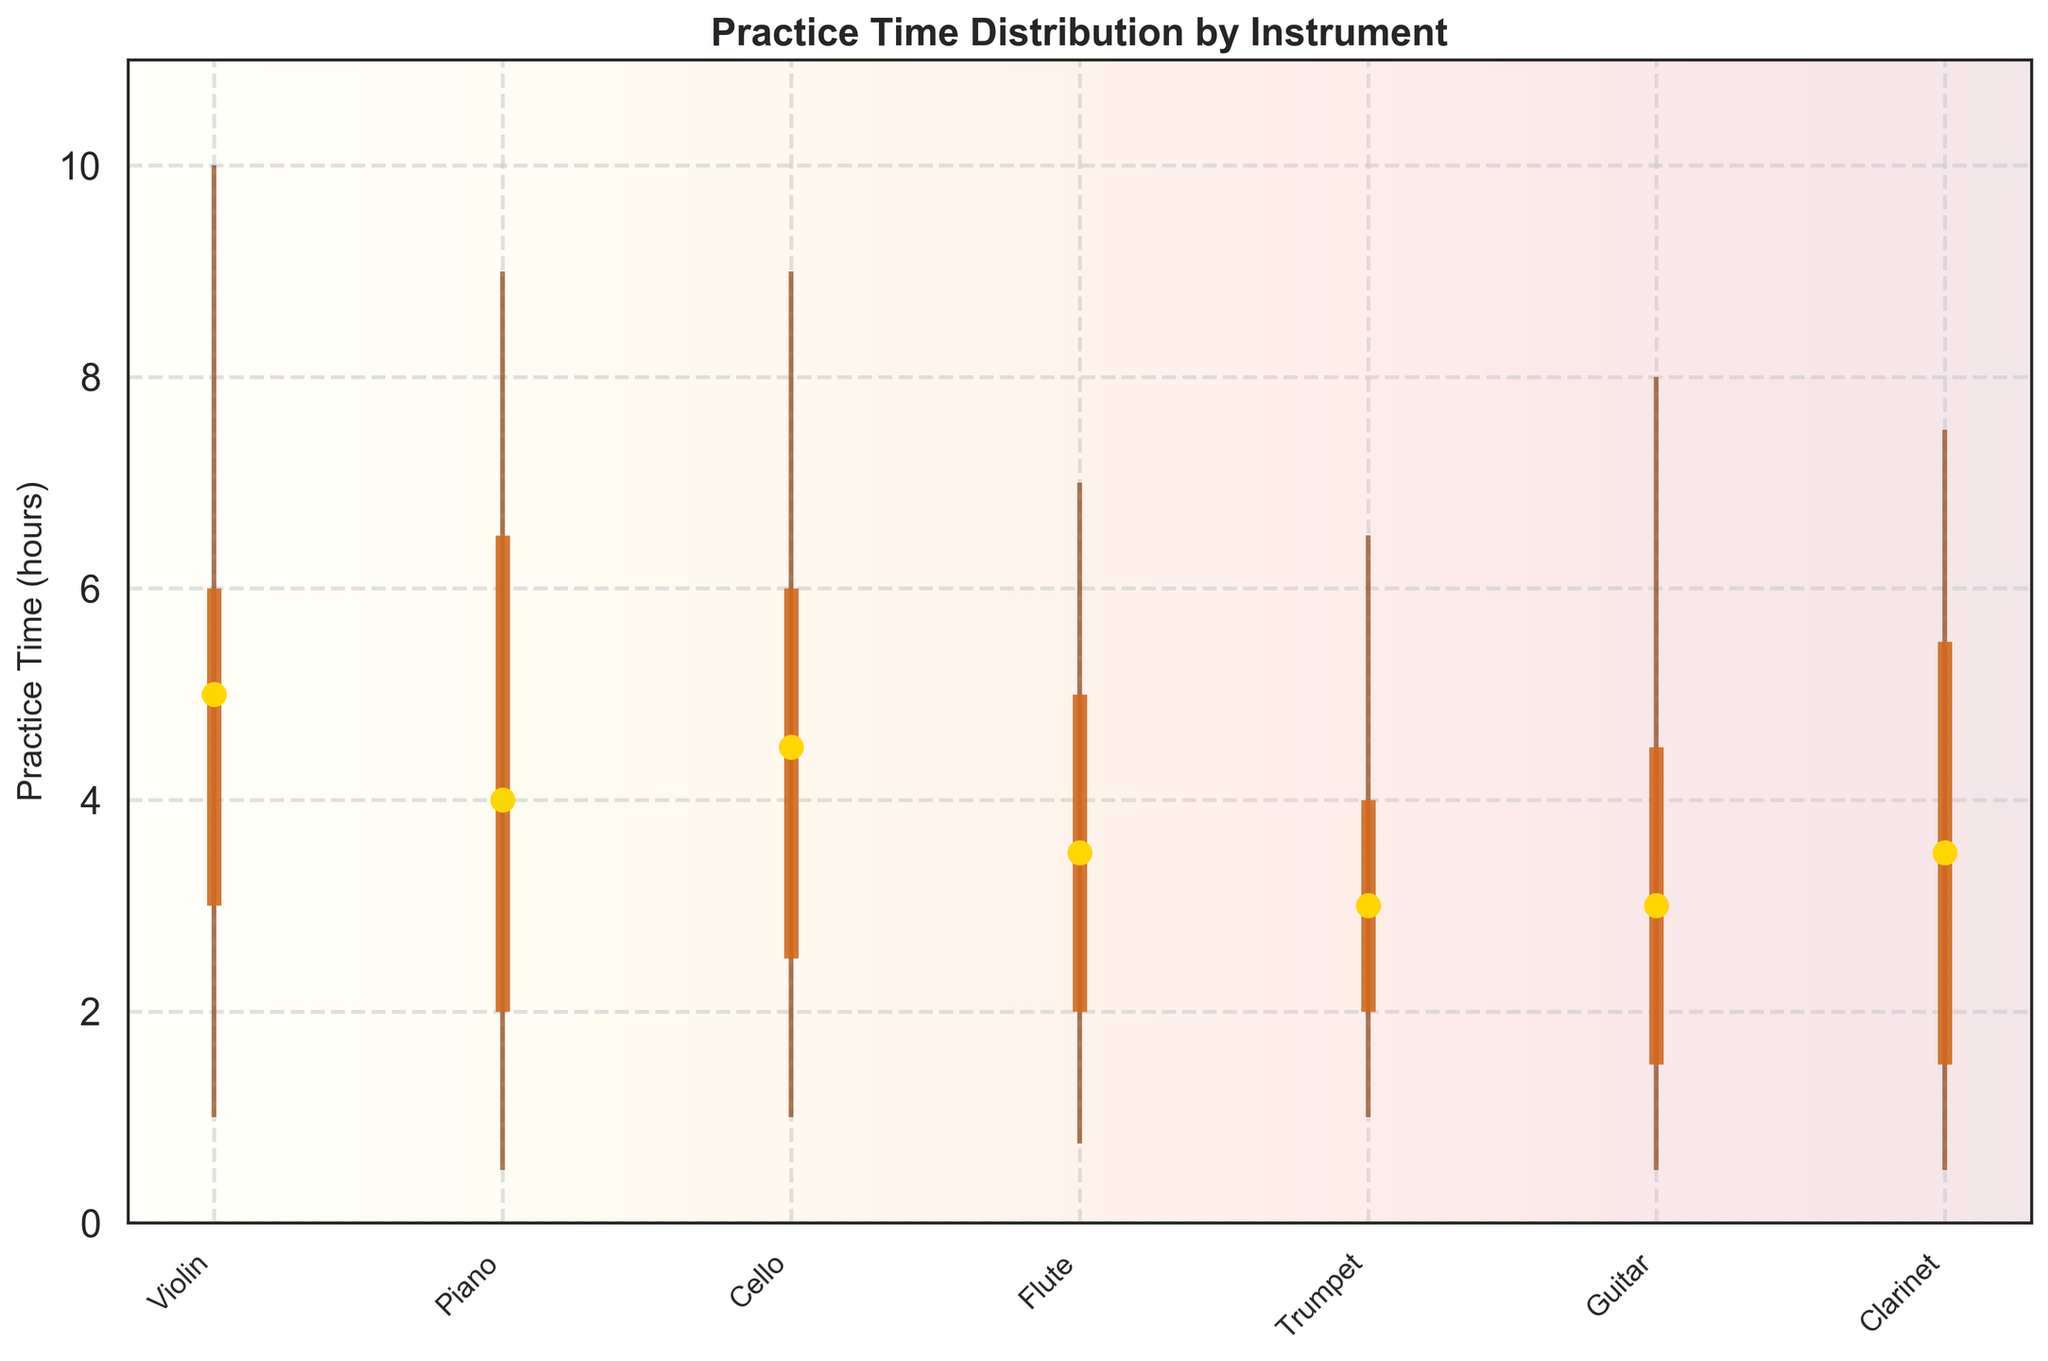What's the title of the candlestick plot? The title of the candlestick plot is usually displayed at the top of the figure. In this case, it reads 'Practice Time Distribution by Instrument'.
Answer: Practice Time Distribution by Instrument Which instrument has the highest maximum practice time? To find this, look at the maximum practice times indicated by the top point of the vertical line for each instrument. The violin has the highest maximum practice time at 10 hours.
Answer: Violin What is the median practice time for the Piano? The median practice time for each instrument is indicated by a gold dot. For the Piano, this dot is at 4 hours.
Answer: 4 hours Which instrument has the smallest range in practice time? To find the smallest range, subtract the minimum from the maximum practice time for each instrument. The Trumpet has the smallest range (6.5 - 1 = 5.5 hours).
Answer: Trumpet What is the difference between the first quartile and the third quartile of practice time for the Cello? The first quartile is at 2.5 hours, and the third quartile is at 6 hours. Subtract the two to get the interquartile range which is 3.5 hours.
Answer: 3.5 hours Which instrument shows the lowest minimum practice time? The minimum practice times are indicated by the bottom point of the vertical line for each instrument. The Piano and Clarinet both have the lowest minimum practice time at 0.5 hours.
Answer: Piano, Clarinet How much more is the maximum practice time of the Violin compared to the Piano? Compare the top points of the vertical lines. Violin's max is 10 hours and Piano's max is 9 hours. The difference is 1 hour.
Answer: 1 hour What is the interquartile range (IQR) for the Trumpet? The first quartile is at 2 hours and the third quartile is at 4 hours. Thus, IQR = Q3 - Q1 = 4 - 2 = 2 hours.
Answer: 2 hours Which instrument has the highest median practice time? The median values are indicated by the gold dots. The Violin has the highest median practice time at 5 hours.
Answer: Violin Is the practice time for the Clarinet more consistent than that for the Guitar? Consistency can be inferred from the range and interquartile range. Clarinet ranges from 0.5-7.5 hours with an IQR of 4 hours, while Guitar ranges from 0.5-8 hours with an IQR of 3 hours. Both have similar consistency, but Clarinet seems slightly broader.
Answer: No, similar 